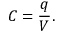<formula> <loc_0><loc_0><loc_500><loc_500>C = { \frac { q } { V } } .</formula> 